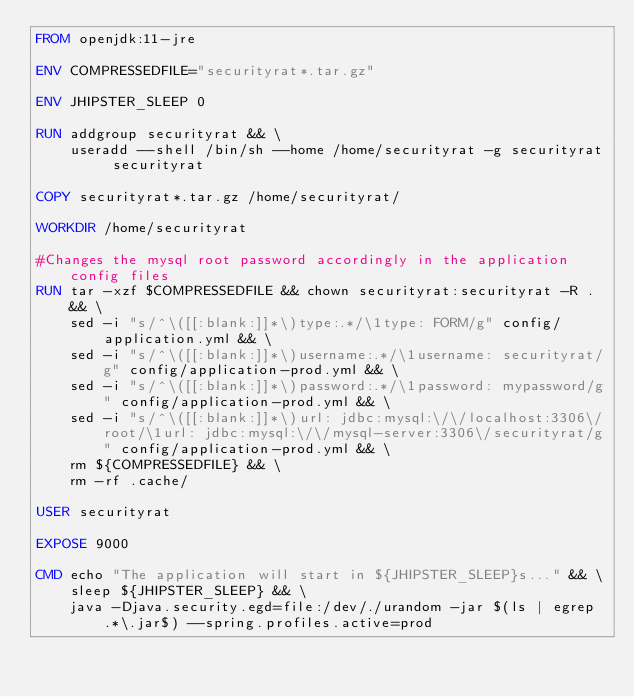<code> <loc_0><loc_0><loc_500><loc_500><_Dockerfile_>FROM openjdk:11-jre

ENV COMPRESSEDFILE="securityrat*.tar.gz"

ENV JHIPSTER_SLEEP 0

RUN addgroup securityrat && \
	useradd --shell /bin/sh --home /home/securityrat -g securityrat securityrat

COPY securityrat*.tar.gz /home/securityrat/

WORKDIR /home/securityrat

#Changes the mysql root password accordingly in the application config files
RUN tar -xzf $COMPRESSEDFILE && chown securityrat:securityrat -R . && \
	sed -i "s/^\([[:blank:]]*\)type:.*/\1type: FORM/g" config/application.yml && \
	sed -i "s/^\([[:blank:]]*\)username:.*/\1username: securityrat/g" config/application-prod.yml && \
	sed -i "s/^\([[:blank:]]*\)password:.*/\1password: mypassword/g" config/application-prod.yml && \
	sed -i "s/^\([[:blank:]]*\)url: jdbc:mysql:\/\/localhost:3306\/root/\1url: jdbc:mysql:\/\/mysql-server:3306\/securityrat/g" config/application-prod.yml && \
	rm ${COMPRESSEDFILE} && \
	rm -rf .cache/

USER securityrat

EXPOSE 9000

CMD echo "The application will start in ${JHIPSTER_SLEEP}s..." && \
	sleep ${JHIPSTER_SLEEP} && \
	java -Djava.security.egd=file:/dev/./urandom -jar $(ls | egrep .*\.jar$) --spring.profiles.active=prod
</code> 